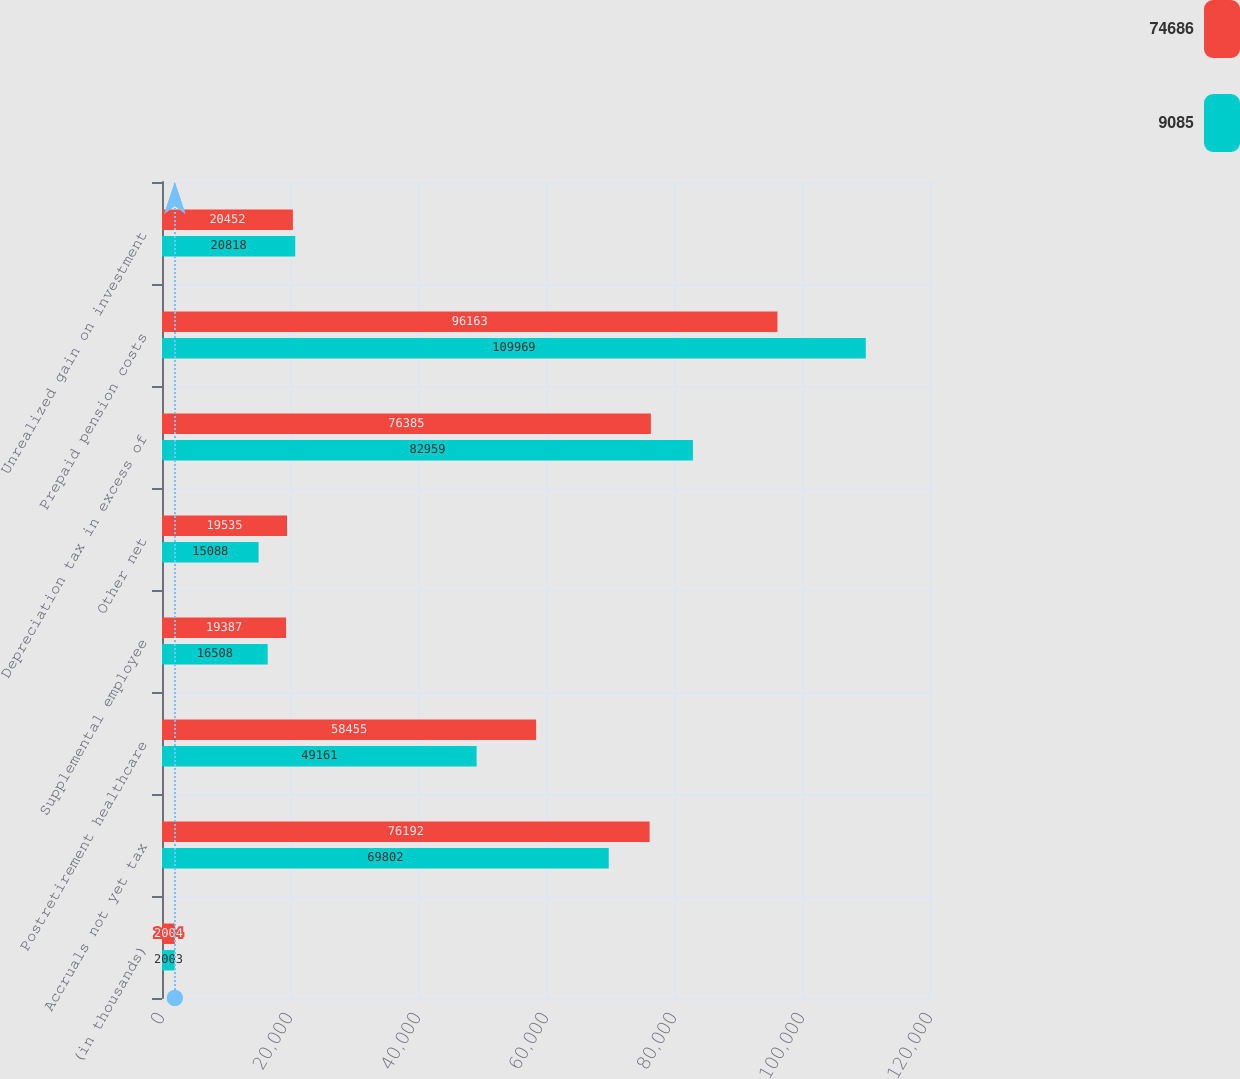Convert chart to OTSL. <chart><loc_0><loc_0><loc_500><loc_500><stacked_bar_chart><ecel><fcel>(in thousands)<fcel>Accruals not yet tax<fcel>Postretirement healthcare<fcel>Supplemental employee<fcel>Other net<fcel>Depreciation tax in excess of<fcel>Prepaid pension costs<fcel>Unrealized gain on investment<nl><fcel>74686<fcel>2004<fcel>76192<fcel>58455<fcel>19387<fcel>19535<fcel>76385<fcel>96163<fcel>20452<nl><fcel>9085<fcel>2003<fcel>69802<fcel>49161<fcel>16508<fcel>15088<fcel>82959<fcel>109969<fcel>20818<nl></chart> 